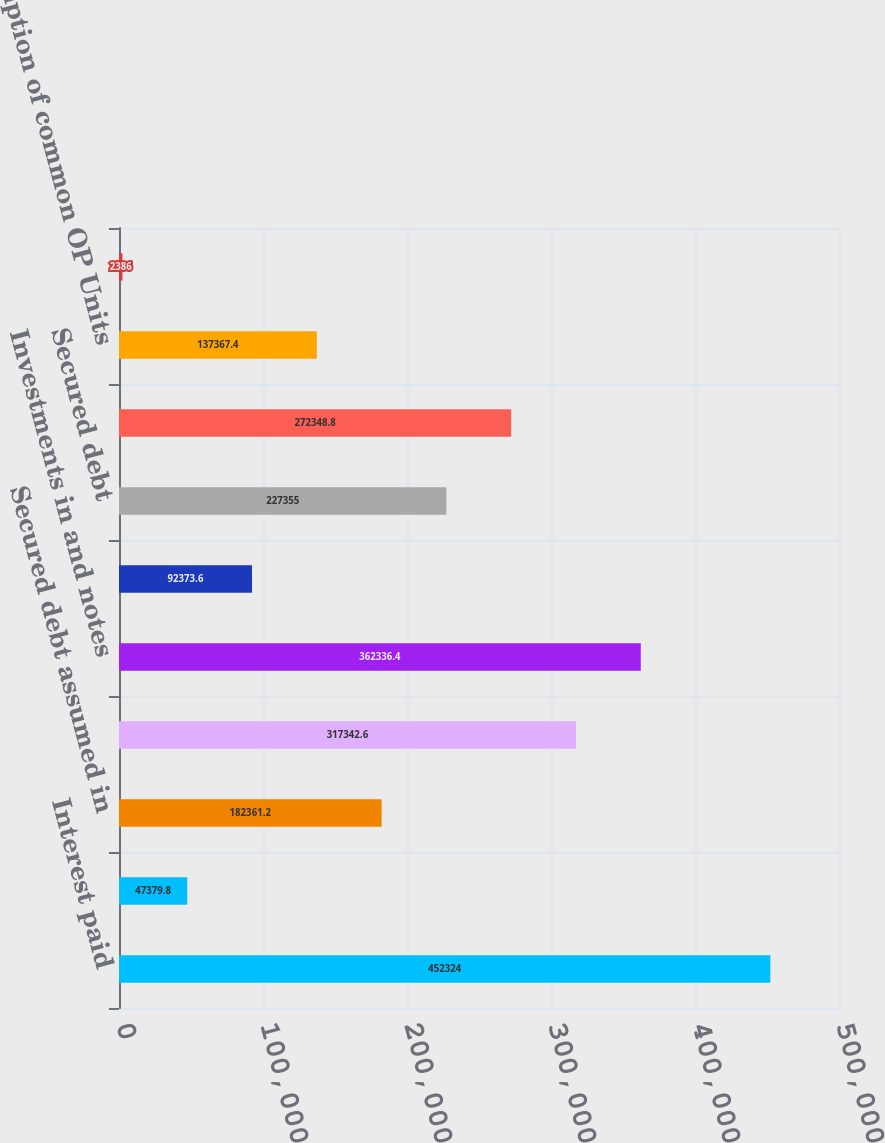<chart> <loc_0><loc_0><loc_500><loc_500><bar_chart><fcel>Interest paid<fcel>Cash paid for income taxes<fcel>Secured debt assumed in<fcel>Real estate net<fcel>Investments in and notes<fcel>Restricted cash and other<fcel>Secured debt<fcel>Accounts payable accrued and<fcel>Redemption of common OP Units<fcel>(Cancellation) origination of<nl><fcel>452324<fcel>47379.8<fcel>182361<fcel>317343<fcel>362336<fcel>92373.6<fcel>227355<fcel>272349<fcel>137367<fcel>2386<nl></chart> 